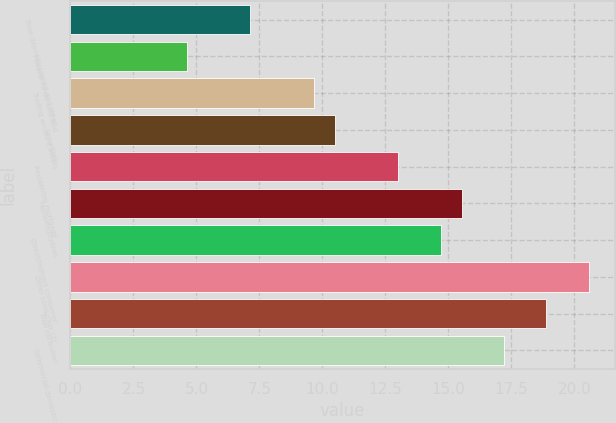Convert chart. <chart><loc_0><loc_0><loc_500><loc_500><bar_chart><fcel>Time deposits placed and other<fcel>Federal funds sold and<fcel>Trading account assets<fcel>Securities<fcel>Residential mortgage<fcel>Homeequitylines<fcel>Direct/Indirect consumer<fcel>Other consumer (2)<fcel>Total consumer<fcel>Commercial-domestic<nl><fcel>7.13<fcel>4.61<fcel>9.65<fcel>10.49<fcel>13.01<fcel>15.53<fcel>14.69<fcel>20.57<fcel>18.89<fcel>17.21<nl></chart> 